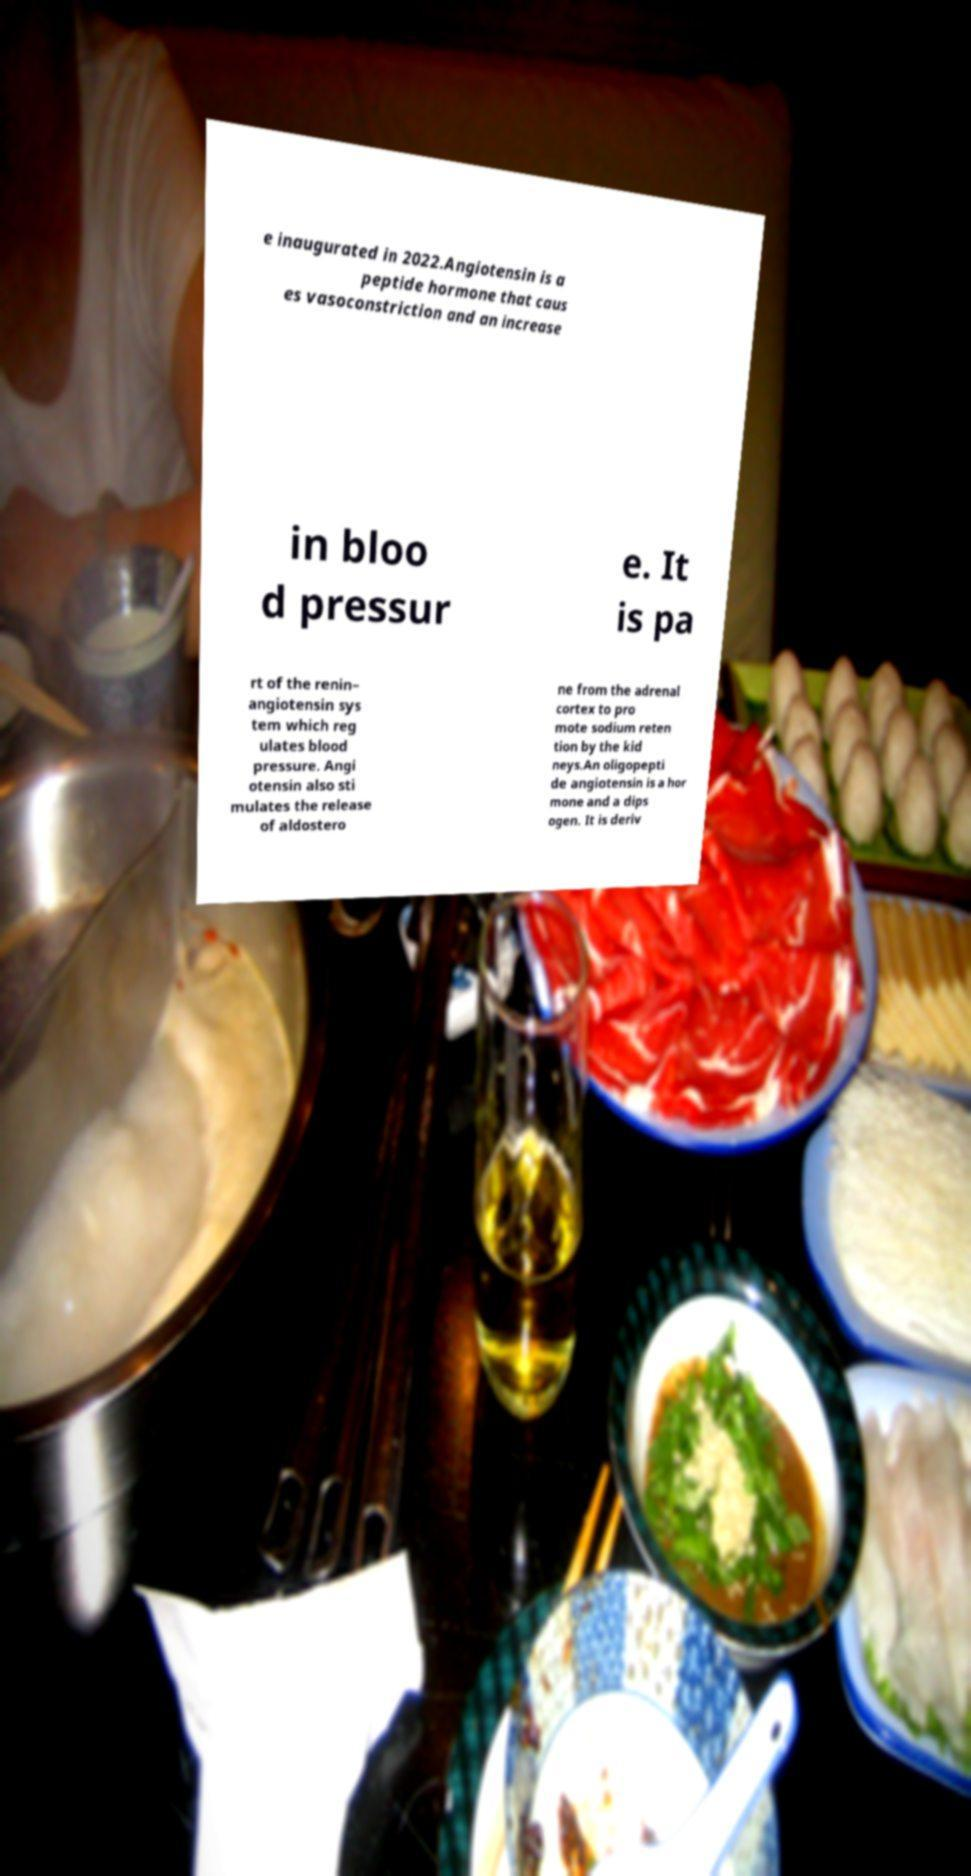I need the written content from this picture converted into text. Can you do that? e inaugurated in 2022.Angiotensin is a peptide hormone that caus es vasoconstriction and an increase in bloo d pressur e. It is pa rt of the renin– angiotensin sys tem which reg ulates blood pressure. Angi otensin also sti mulates the release of aldostero ne from the adrenal cortex to pro mote sodium reten tion by the kid neys.An oligopepti de angiotensin is a hor mone and a dips ogen. It is deriv 